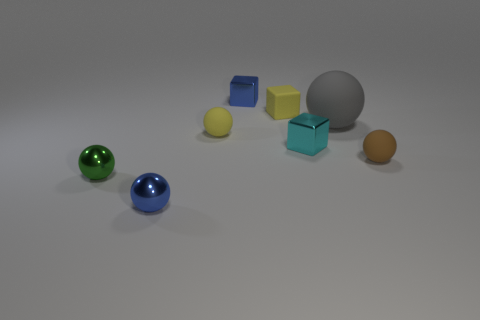What is the shape of the matte thing left of the blue object behind the tiny cyan metal thing?
Ensure brevity in your answer.  Sphere. Are any spheres visible?
Your response must be concise. Yes. What is the color of the rubber object behind the gray sphere?
Your response must be concise. Yellow. There is a sphere that is the same color as the small rubber block; what material is it?
Your answer should be very brief. Rubber. Are there any gray matte spheres in front of the matte block?
Keep it short and to the point. Yes. Is the number of blue matte cylinders greater than the number of tiny cyan cubes?
Give a very brief answer. No. What color is the metal block in front of the blue metal object that is right of the small matte sphere that is to the left of the brown rubber thing?
Offer a very short reply. Cyan. There is a large ball that is the same material as the tiny brown thing; what is its color?
Make the answer very short. Gray. Is there any other thing that is the same size as the cyan object?
Ensure brevity in your answer.  Yes. What number of things are tiny blue shiny things that are behind the blue metallic ball or metallic blocks in front of the large thing?
Your answer should be very brief. 2. 